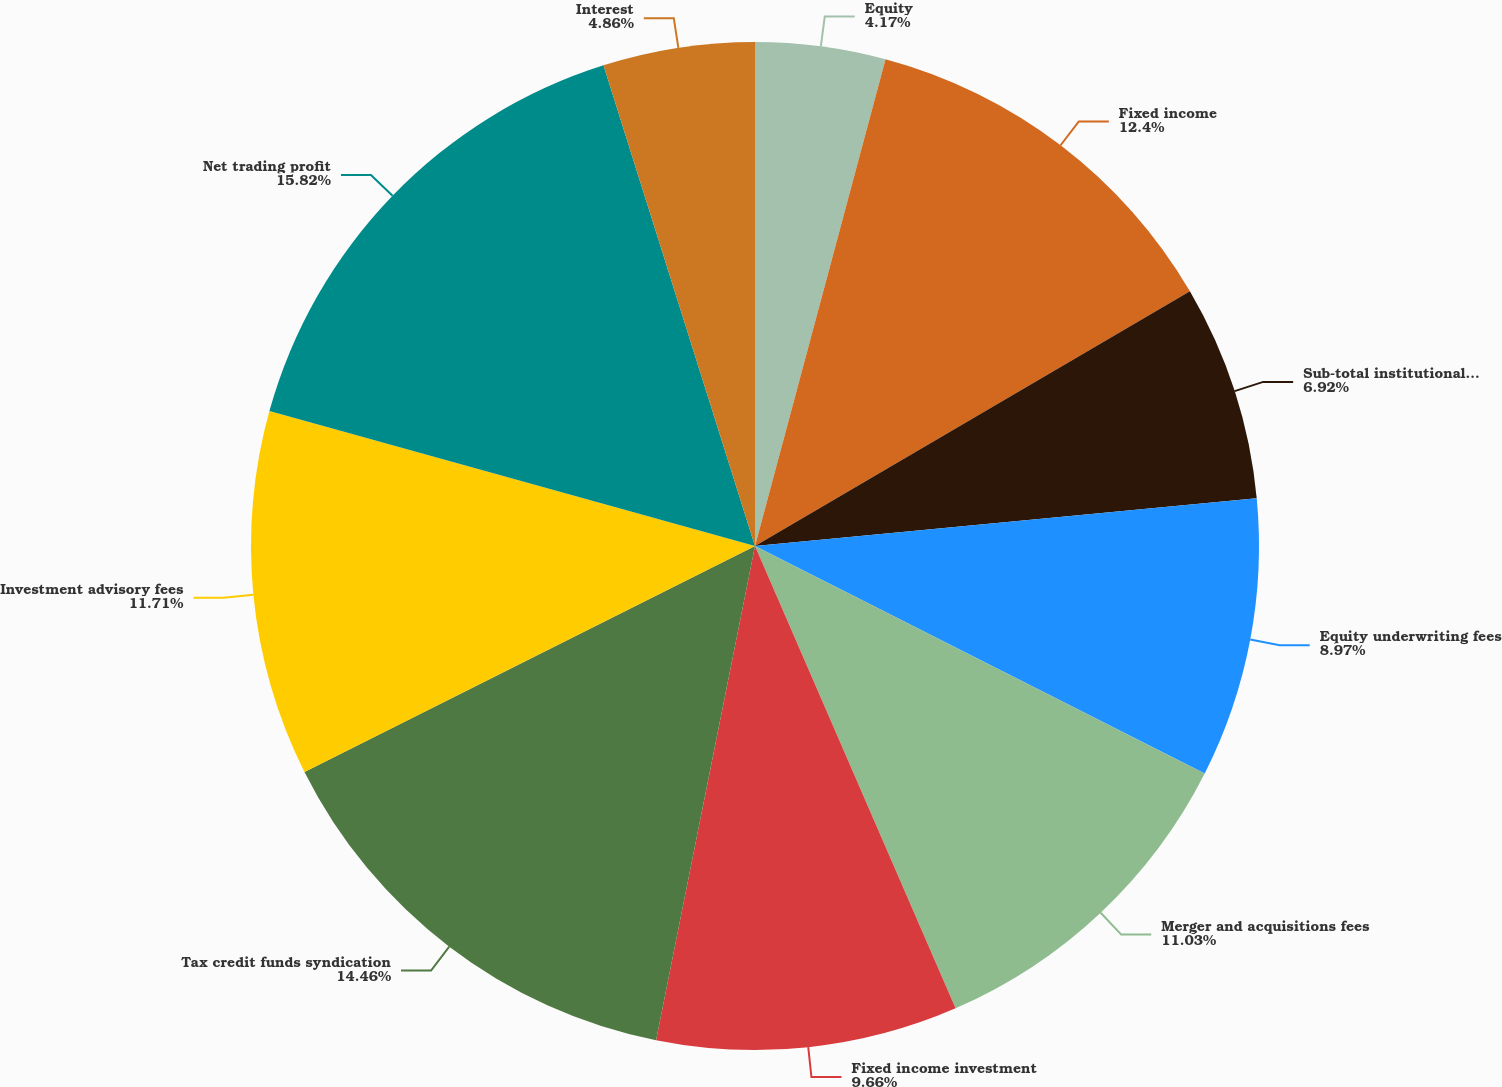Convert chart. <chart><loc_0><loc_0><loc_500><loc_500><pie_chart><fcel>Equity<fcel>Fixed income<fcel>Sub-total institutional sales<fcel>Equity underwriting fees<fcel>Merger and acquisitions fees<fcel>Fixed income investment<fcel>Tax credit funds syndication<fcel>Investment advisory fees<fcel>Net trading profit<fcel>Interest<nl><fcel>4.17%<fcel>12.4%<fcel>6.92%<fcel>8.97%<fcel>11.03%<fcel>9.66%<fcel>14.46%<fcel>11.71%<fcel>15.83%<fcel>4.86%<nl></chart> 